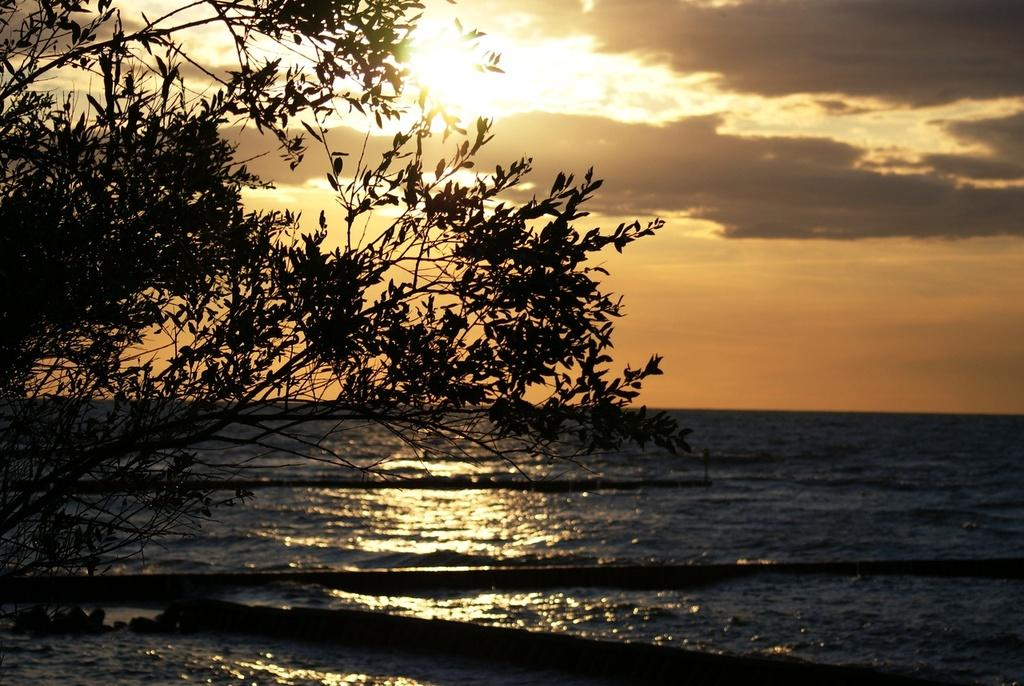What is the main feature of the image? There is a large water body in the image. Are there any other natural elements present in the image? Yes, there is a tree and stones visible in the image. What is the weather like in the image? The sky appears cloudy in the image. Can you see the sun in the image? Yes, the sun is visible in the image. What scent can be detected from the stones in the image? There is no information about the scent of the stones in the image, as it is a visual medium. 